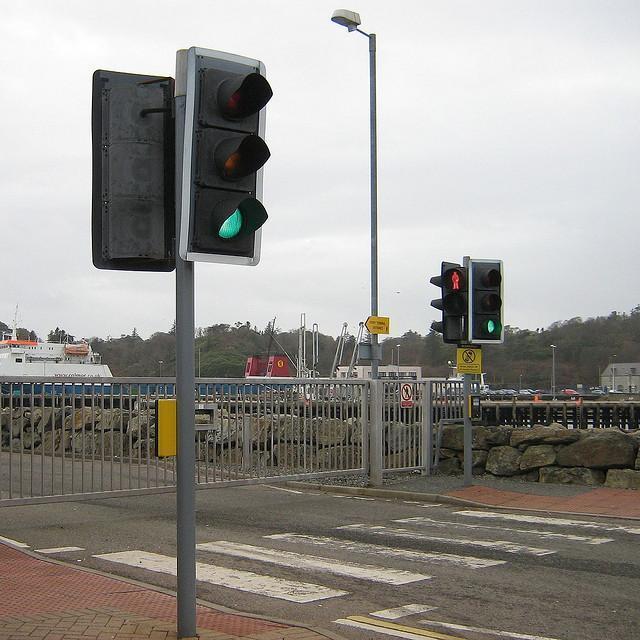What type of surface can be found past the rock wall to the right of the road?
Answer the question by selecting the correct answer among the 4 following choices.
Options: Gravel, water, sand, grass. Water. 